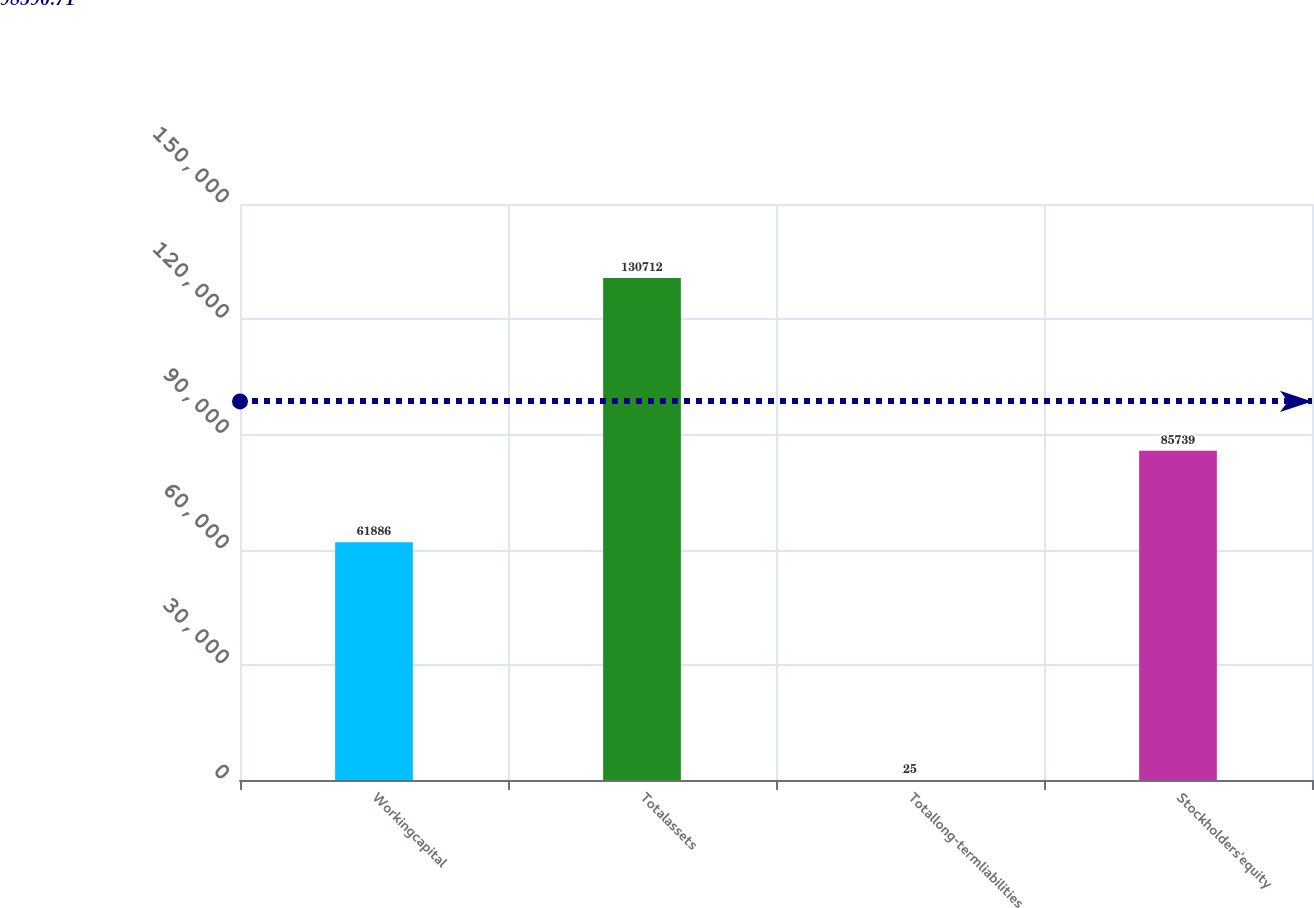<chart> <loc_0><loc_0><loc_500><loc_500><bar_chart><fcel>Workingcapital<fcel>Totalassets<fcel>Totallong-termliabilities<fcel>Stockholders'equity<nl><fcel>61886<fcel>130712<fcel>25<fcel>85739<nl></chart> 